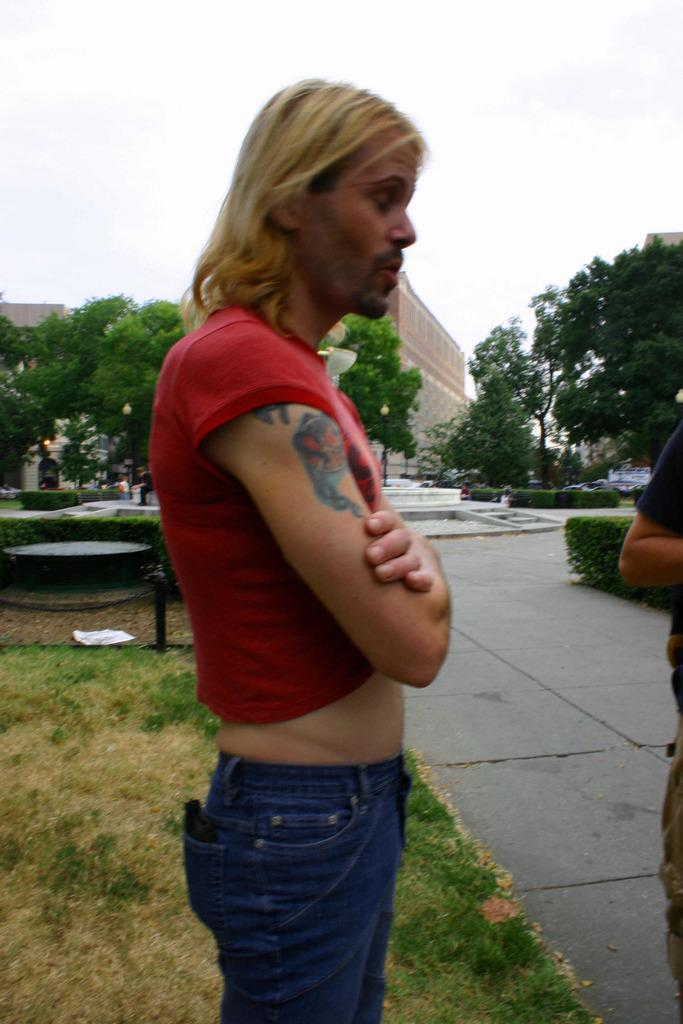Who or what can be seen in the image? There are people in the image. What can be seen in the distance behind the people? There are trees, buildings, and the sky visible in the background of the image. What type of terrain is at the bottom of the image? There is grass at the bottom of the image. What type of prose is being recited by the trees in the image? There are no trees reciting prose in the image; the trees are simply part of the background. 